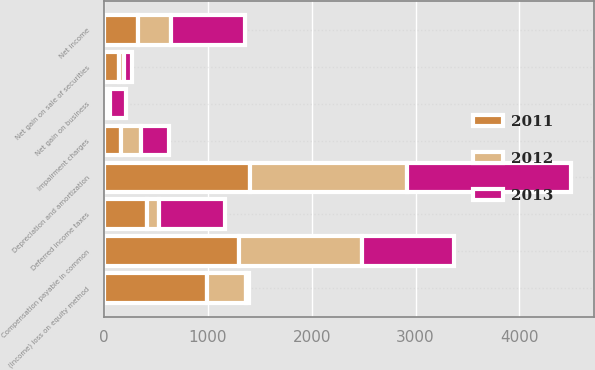Convert chart to OTSL. <chart><loc_0><loc_0><loc_500><loc_500><stacked_bar_chart><ecel><fcel>Net income<fcel>Deferred income taxes<fcel>(Income) loss on equity method<fcel>Compensation payable in common<fcel>Depreciation and amortization<fcel>Net gain on business<fcel>Net gain on sale of securities<fcel>Impairment charges<nl><fcel>2012<fcel>323<fcel>117<fcel>375<fcel>1180<fcel>1511<fcel>34<fcel>45<fcel>198<nl><fcel>2013<fcel>716<fcel>639<fcel>23<fcel>891<fcel>1581<fcel>156<fcel>78<fcel>271<nl><fcel>2011<fcel>323<fcel>413<fcel>995<fcel>1300<fcel>1404<fcel>24<fcel>143<fcel>159<nl></chart> 